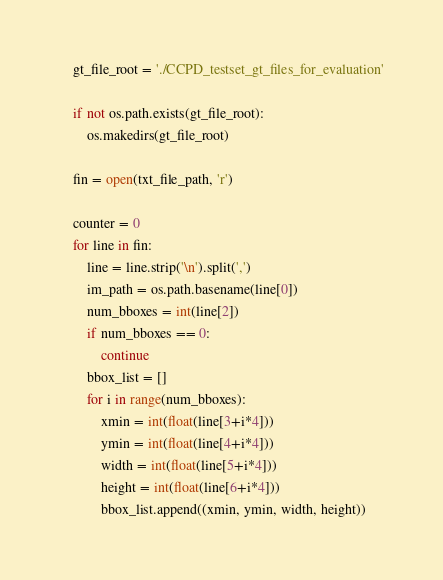Convert code to text. <code><loc_0><loc_0><loc_500><loc_500><_Python_>    gt_file_root = './CCPD_testset_gt_files_for_evaluation'

    if not os.path.exists(gt_file_root):
        os.makedirs(gt_file_root)

    fin = open(txt_file_path, 'r')

    counter = 0
    for line in fin:
        line = line.strip('\n').split(',')
        im_path = os.path.basename(line[0])
        num_bboxes = int(line[2])
        if num_bboxes == 0:
            continue
        bbox_list = []
        for i in range(num_bboxes):
            xmin = int(float(line[3+i*4]))
            ymin = int(float(line[4+i*4]))
            width = int(float(line[5+i*4]))
            height = int(float(line[6+i*4]))
            bbox_list.append((xmin, ymin, width, height))
</code> 